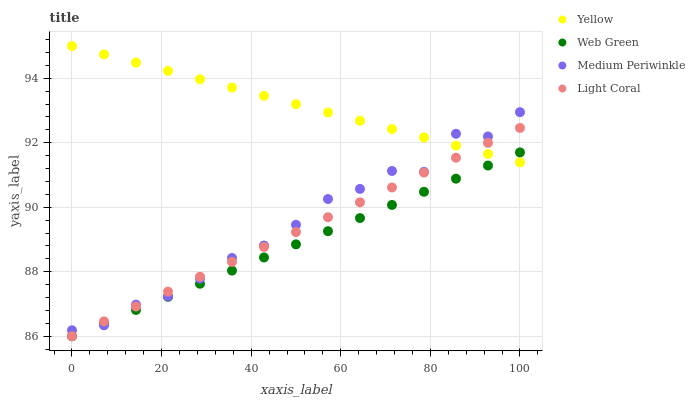Does Web Green have the minimum area under the curve?
Answer yes or no. Yes. Does Yellow have the maximum area under the curve?
Answer yes or no. Yes. Does Medium Periwinkle have the minimum area under the curve?
Answer yes or no. No. Does Medium Periwinkle have the maximum area under the curve?
Answer yes or no. No. Is Web Green the smoothest?
Answer yes or no. Yes. Is Medium Periwinkle the roughest?
Answer yes or no. Yes. Is Medium Periwinkle the smoothest?
Answer yes or no. No. Is Web Green the roughest?
Answer yes or no. No. Does Light Coral have the lowest value?
Answer yes or no. Yes. Does Medium Periwinkle have the lowest value?
Answer yes or no. No. Does Yellow have the highest value?
Answer yes or no. Yes. Does Medium Periwinkle have the highest value?
Answer yes or no. No. Does Light Coral intersect Medium Periwinkle?
Answer yes or no. Yes. Is Light Coral less than Medium Periwinkle?
Answer yes or no. No. Is Light Coral greater than Medium Periwinkle?
Answer yes or no. No. 